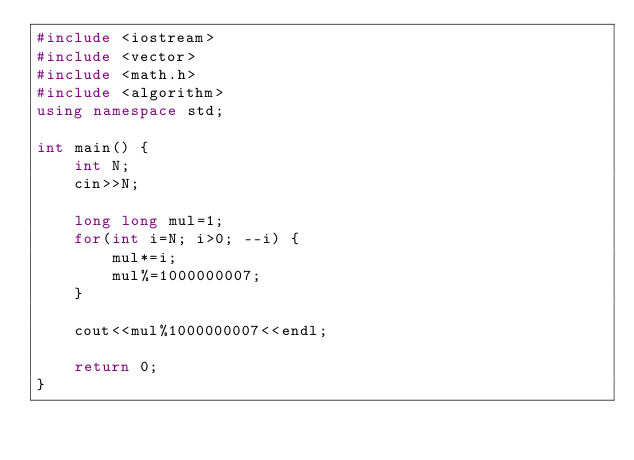<code> <loc_0><loc_0><loc_500><loc_500><_C++_>#include <iostream>
#include <vector>
#include <math.h>
#include <algorithm>
using namespace std;

int main() {
    int N;
    cin>>N;

    long long mul=1;
    for(int i=N; i>0; --i) {
        mul*=i;
        mul%=1000000007;
    }

    cout<<mul%1000000007<<endl;

    return 0;
}</code> 